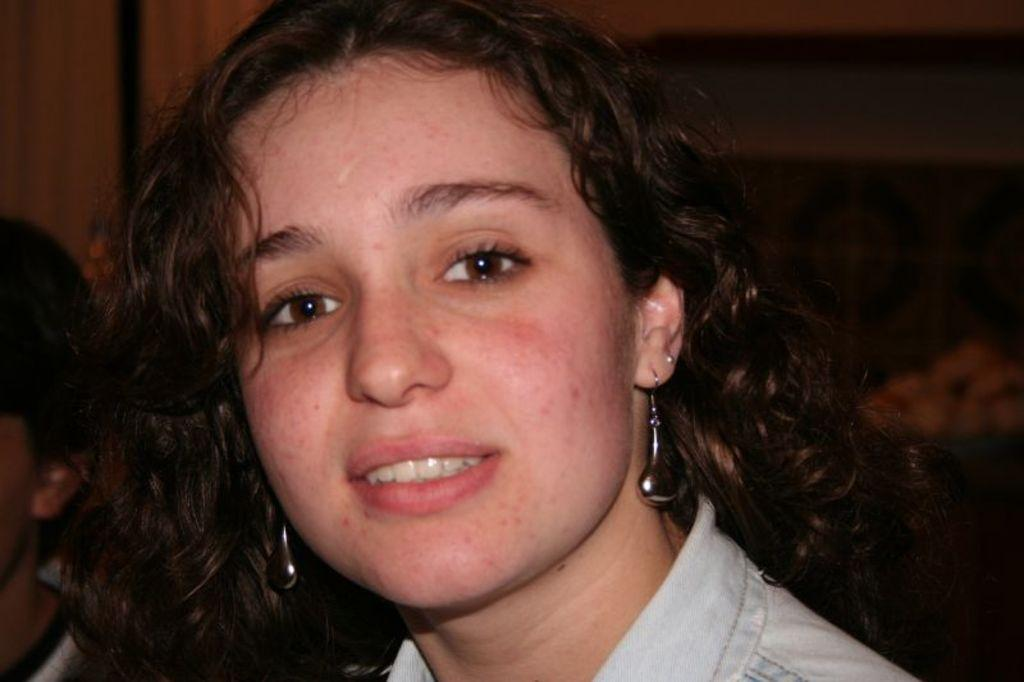Who is present in the image? There is a woman in the image. What is the woman doing in the image? The woman is smiling in the image. Can you describe the background of the image? The background of the image appears blurry. Are there any other people in the image besides the woman? Yes, there is another person in the left corner of the image. What type of knee injury does the woman have in the image? There is no indication of a knee injury in the image; the woman is simply smiling. 